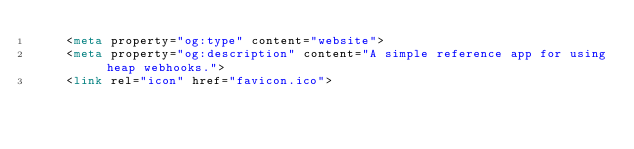<code> <loc_0><loc_0><loc_500><loc_500><_HTML_>    <meta property="og:type" content="website">
    <meta property="og:description" content="A simple reference app for using heap webhooks.">
    <link rel="icon" href="favicon.ico"></code> 